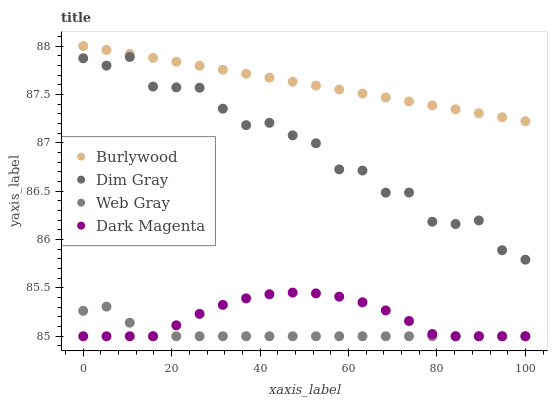Does Web Gray have the minimum area under the curve?
Answer yes or no. Yes. Does Burlywood have the maximum area under the curve?
Answer yes or no. Yes. Does Dim Gray have the minimum area under the curve?
Answer yes or no. No. Does Dim Gray have the maximum area under the curve?
Answer yes or no. No. Is Burlywood the smoothest?
Answer yes or no. Yes. Is Dim Gray the roughest?
Answer yes or no. Yes. Is Web Gray the smoothest?
Answer yes or no. No. Is Web Gray the roughest?
Answer yes or no. No. Does Web Gray have the lowest value?
Answer yes or no. Yes. Does Dim Gray have the lowest value?
Answer yes or no. No. Does Burlywood have the highest value?
Answer yes or no. Yes. Does Dim Gray have the highest value?
Answer yes or no. No. Is Dark Magenta less than Burlywood?
Answer yes or no. Yes. Is Burlywood greater than Web Gray?
Answer yes or no. Yes. Does Dark Magenta intersect Web Gray?
Answer yes or no. Yes. Is Dark Magenta less than Web Gray?
Answer yes or no. No. Is Dark Magenta greater than Web Gray?
Answer yes or no. No. Does Dark Magenta intersect Burlywood?
Answer yes or no. No. 